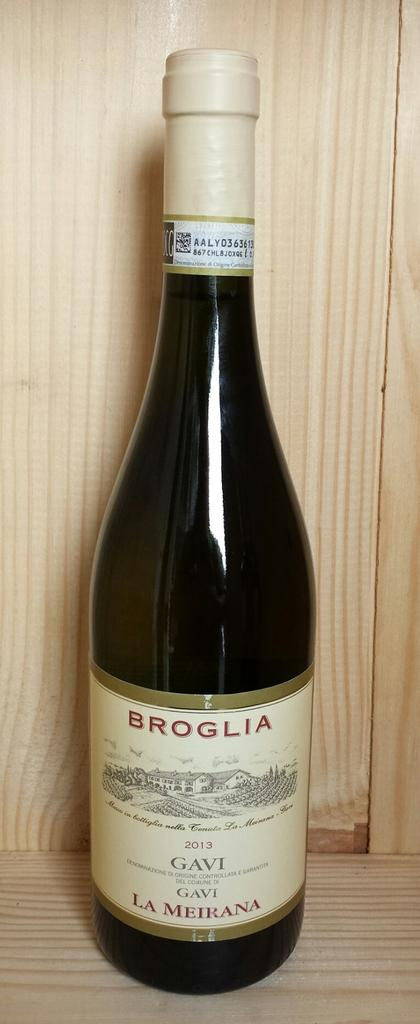<image>
Render a clear and concise summary of the photo. a bottle of Broglia Gavi wine in a wood case 